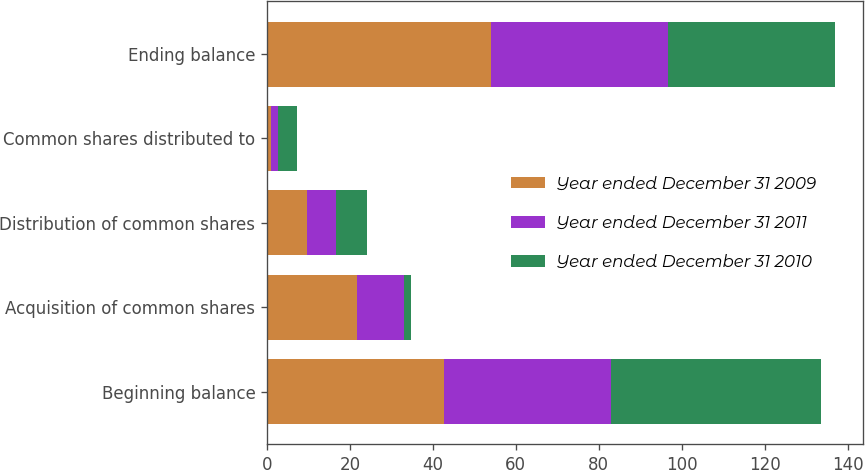Convert chart to OTSL. <chart><loc_0><loc_0><loc_500><loc_500><stacked_bar_chart><ecel><fcel>Beginning balance<fcel>Acquisition of common shares<fcel>Distribution of common shares<fcel>Common shares distributed to<fcel>Ending balance<nl><fcel>Year ended December 31 2009<fcel>42.7<fcel>21.8<fcel>9.6<fcel>0.9<fcel>54<nl><fcel>Year ended December 31 2011<fcel>40.2<fcel>11.3<fcel>7<fcel>1.8<fcel>42.7<nl><fcel>Year ended December 31 2010<fcel>50.7<fcel>1.6<fcel>7.5<fcel>4.6<fcel>40.2<nl></chart> 